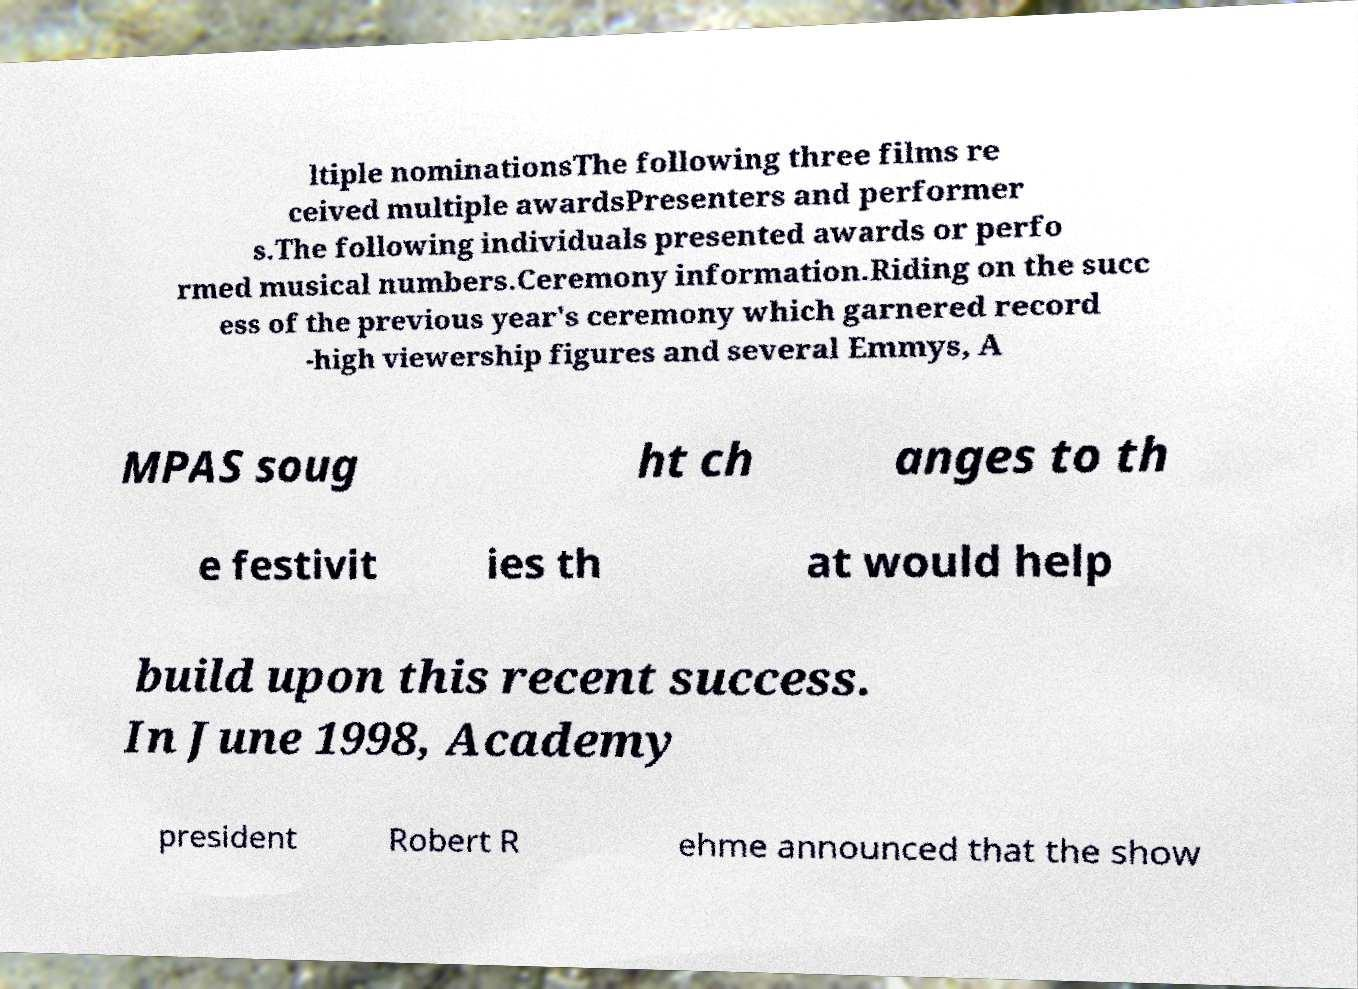Could you assist in decoding the text presented in this image and type it out clearly? ltiple nominationsThe following three films re ceived multiple awardsPresenters and performer s.The following individuals presented awards or perfo rmed musical numbers.Ceremony information.Riding on the succ ess of the previous year's ceremony which garnered record -high viewership figures and several Emmys, A MPAS soug ht ch anges to th e festivit ies th at would help build upon this recent success. In June 1998, Academy president Robert R ehme announced that the show 